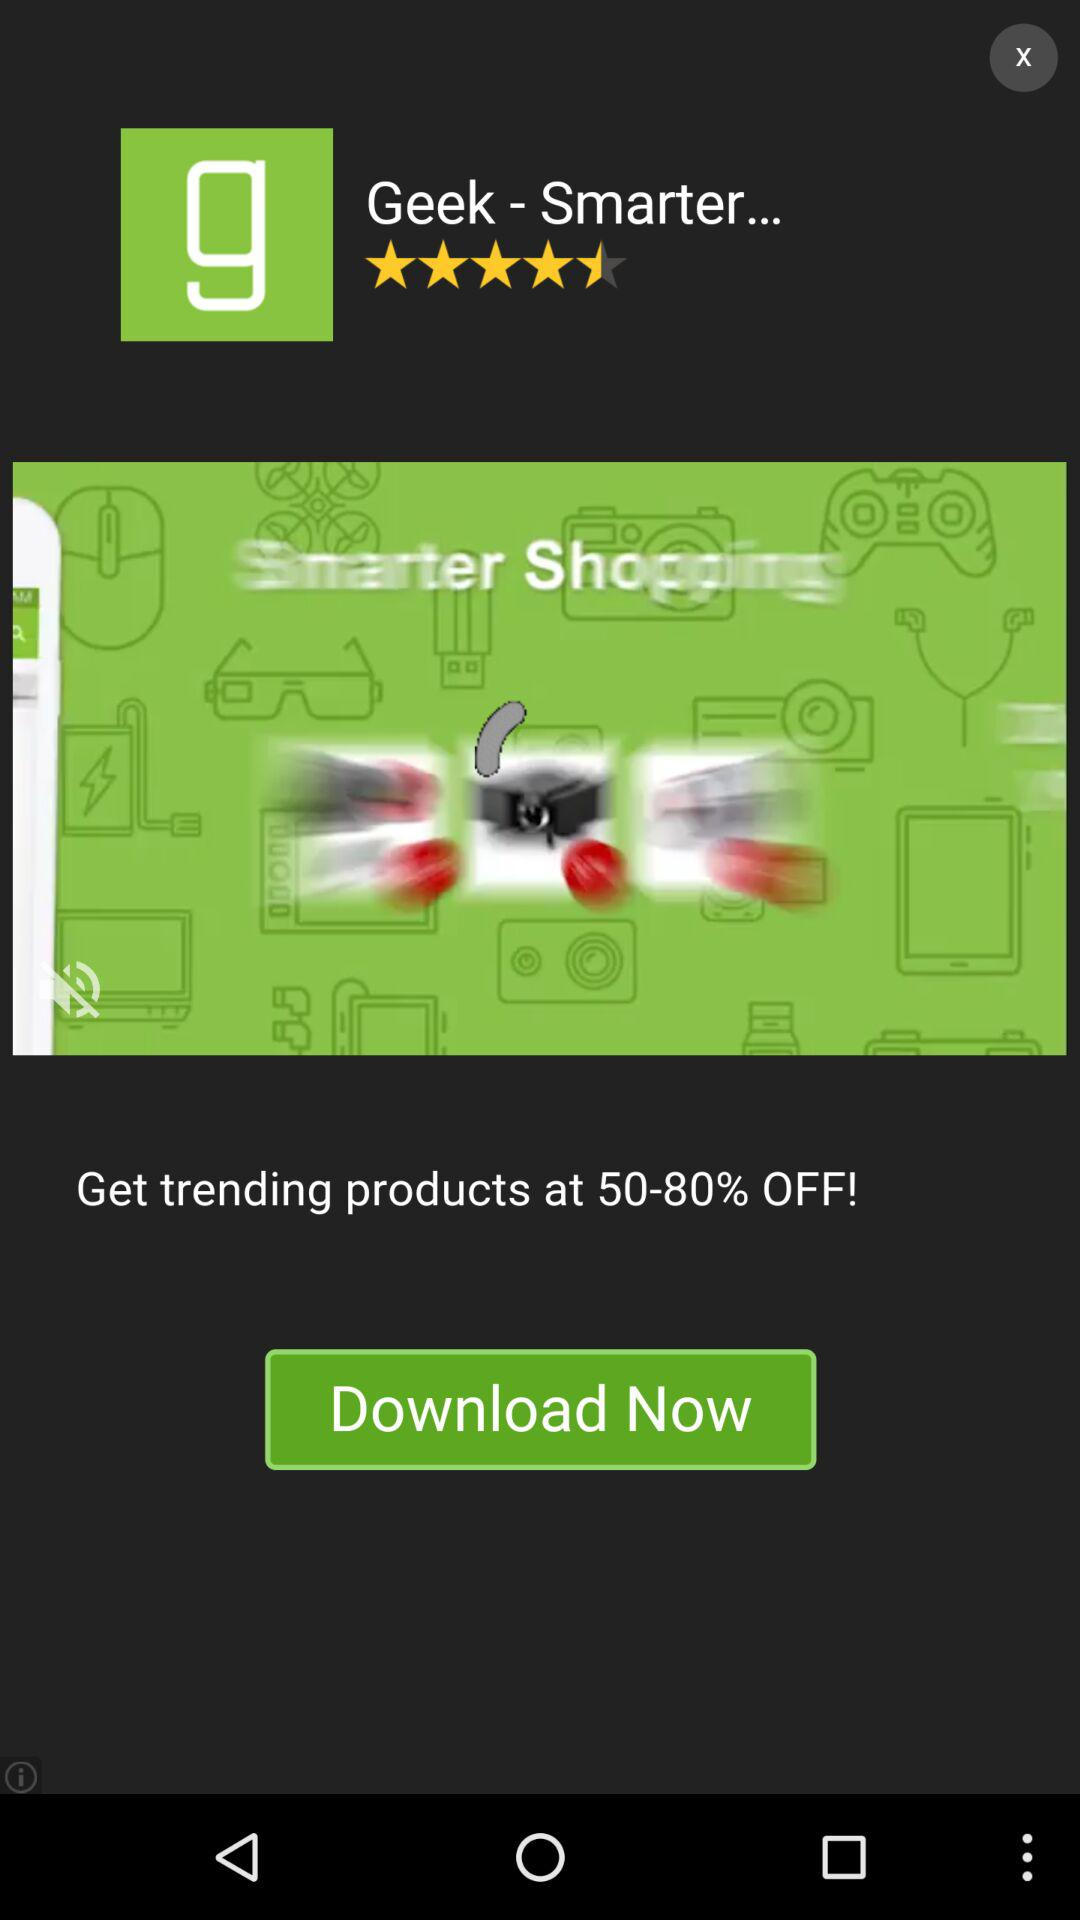What is the name of the application? The name of the application is "Geek - Smarter...". 